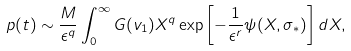Convert formula to latex. <formula><loc_0><loc_0><loc_500><loc_500>p ( t ) \sim \frac { M } { \epsilon ^ { q } } \int _ { 0 } ^ { \infty } G ( v _ { 1 } ) X ^ { q } \exp \left [ - \frac { 1 } { \epsilon ^ { r } } \psi ( X , \sigma _ { * } ) \right ] d X ,</formula> 